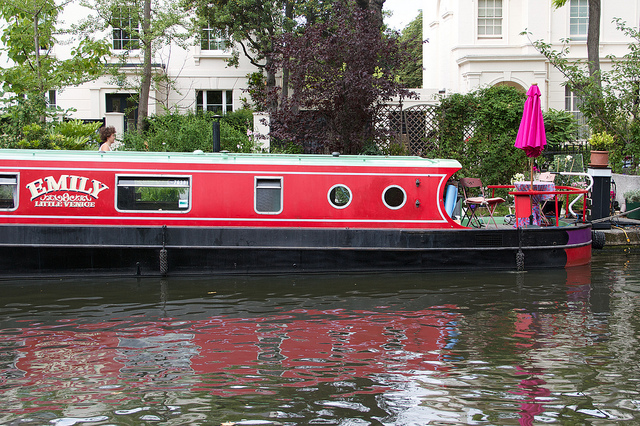Read and extract the text from this image. EMILY LITTLE VENICE 